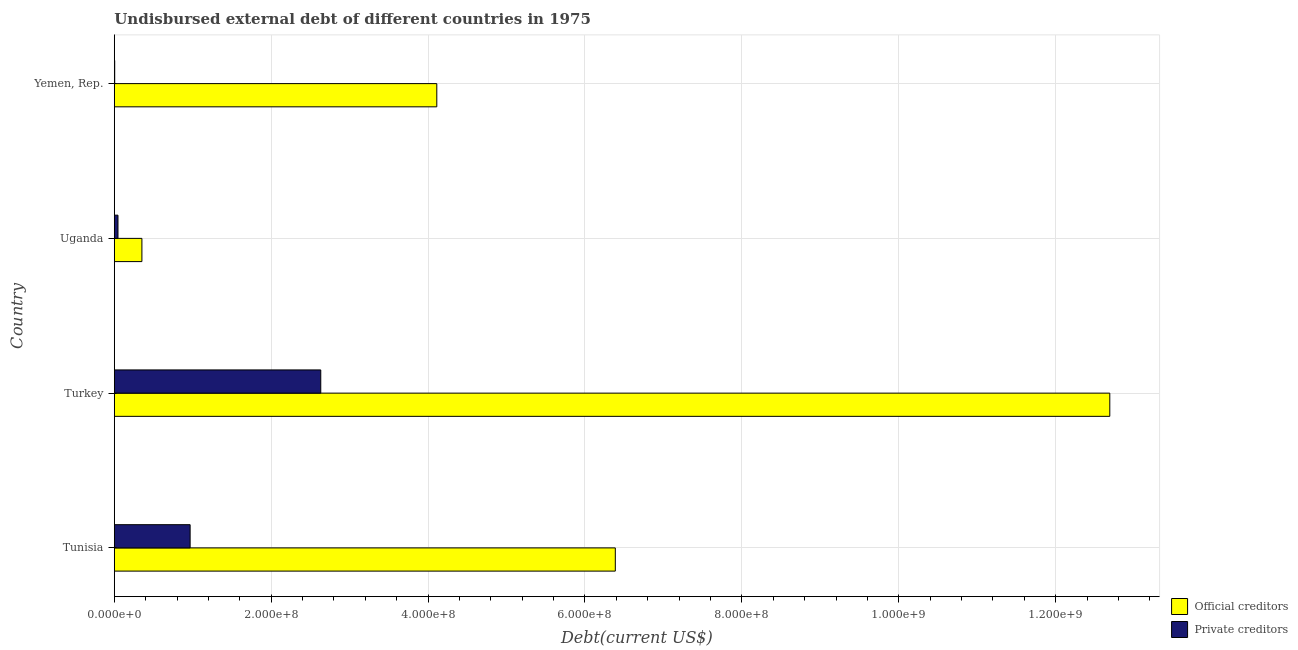Are the number of bars per tick equal to the number of legend labels?
Give a very brief answer. Yes. How many bars are there on the 4th tick from the top?
Ensure brevity in your answer.  2. How many bars are there on the 1st tick from the bottom?
Your answer should be very brief. 2. What is the label of the 1st group of bars from the top?
Offer a terse response. Yemen, Rep. What is the undisbursed external debt of private creditors in Yemen, Rep.?
Provide a succinct answer. 5.02e+05. Across all countries, what is the maximum undisbursed external debt of private creditors?
Make the answer very short. 2.63e+08. Across all countries, what is the minimum undisbursed external debt of private creditors?
Keep it short and to the point. 5.02e+05. In which country was the undisbursed external debt of official creditors minimum?
Provide a succinct answer. Uganda. What is the total undisbursed external debt of official creditors in the graph?
Your answer should be compact. 2.35e+09. What is the difference between the undisbursed external debt of private creditors in Turkey and that in Yemen, Rep.?
Provide a succinct answer. 2.63e+08. What is the difference between the undisbursed external debt of official creditors in Yemen, Rep. and the undisbursed external debt of private creditors in Tunisia?
Your response must be concise. 3.14e+08. What is the average undisbursed external debt of official creditors per country?
Keep it short and to the point. 5.88e+08. What is the difference between the undisbursed external debt of private creditors and undisbursed external debt of official creditors in Yemen, Rep.?
Keep it short and to the point. -4.11e+08. In how many countries, is the undisbursed external debt of official creditors greater than 1040000000 US$?
Give a very brief answer. 1. What is the ratio of the undisbursed external debt of private creditors in Uganda to that in Yemen, Rep.?
Keep it short and to the point. 9.33. Is the undisbursed external debt of official creditors in Turkey less than that in Uganda?
Your answer should be compact. No. Is the difference between the undisbursed external debt of private creditors in Tunisia and Yemen, Rep. greater than the difference between the undisbursed external debt of official creditors in Tunisia and Yemen, Rep.?
Give a very brief answer. No. What is the difference between the highest and the second highest undisbursed external debt of official creditors?
Your answer should be compact. 6.30e+08. What is the difference between the highest and the lowest undisbursed external debt of private creditors?
Provide a short and direct response. 2.63e+08. What does the 1st bar from the top in Turkey represents?
Provide a short and direct response. Private creditors. What does the 2nd bar from the bottom in Tunisia represents?
Ensure brevity in your answer.  Private creditors. Are all the bars in the graph horizontal?
Provide a succinct answer. Yes. How many countries are there in the graph?
Ensure brevity in your answer.  4. Does the graph contain any zero values?
Provide a succinct answer. No. Does the graph contain grids?
Ensure brevity in your answer.  Yes. How are the legend labels stacked?
Make the answer very short. Vertical. What is the title of the graph?
Provide a short and direct response. Undisbursed external debt of different countries in 1975. What is the label or title of the X-axis?
Keep it short and to the point. Debt(current US$). What is the label or title of the Y-axis?
Your response must be concise. Country. What is the Debt(current US$) of Official creditors in Tunisia?
Offer a very short reply. 6.39e+08. What is the Debt(current US$) of Private creditors in Tunisia?
Keep it short and to the point. 9.67e+07. What is the Debt(current US$) of Official creditors in Turkey?
Ensure brevity in your answer.  1.27e+09. What is the Debt(current US$) of Private creditors in Turkey?
Your response must be concise. 2.63e+08. What is the Debt(current US$) in Official creditors in Uganda?
Offer a terse response. 3.52e+07. What is the Debt(current US$) of Private creditors in Uganda?
Keep it short and to the point. 4.68e+06. What is the Debt(current US$) of Official creditors in Yemen, Rep.?
Offer a terse response. 4.11e+08. What is the Debt(current US$) of Private creditors in Yemen, Rep.?
Ensure brevity in your answer.  5.02e+05. Across all countries, what is the maximum Debt(current US$) in Official creditors?
Your response must be concise. 1.27e+09. Across all countries, what is the maximum Debt(current US$) in Private creditors?
Your answer should be compact. 2.63e+08. Across all countries, what is the minimum Debt(current US$) in Official creditors?
Your response must be concise. 3.52e+07. Across all countries, what is the minimum Debt(current US$) in Private creditors?
Provide a succinct answer. 5.02e+05. What is the total Debt(current US$) in Official creditors in the graph?
Your answer should be compact. 2.35e+09. What is the total Debt(current US$) in Private creditors in the graph?
Provide a succinct answer. 3.65e+08. What is the difference between the Debt(current US$) of Official creditors in Tunisia and that in Turkey?
Offer a very short reply. -6.30e+08. What is the difference between the Debt(current US$) in Private creditors in Tunisia and that in Turkey?
Provide a short and direct response. -1.67e+08. What is the difference between the Debt(current US$) in Official creditors in Tunisia and that in Uganda?
Offer a very short reply. 6.03e+08. What is the difference between the Debt(current US$) in Private creditors in Tunisia and that in Uganda?
Offer a very short reply. 9.20e+07. What is the difference between the Debt(current US$) in Official creditors in Tunisia and that in Yemen, Rep.?
Your response must be concise. 2.28e+08. What is the difference between the Debt(current US$) in Private creditors in Tunisia and that in Yemen, Rep.?
Offer a terse response. 9.62e+07. What is the difference between the Debt(current US$) of Official creditors in Turkey and that in Uganda?
Your response must be concise. 1.23e+09. What is the difference between the Debt(current US$) in Private creditors in Turkey and that in Uganda?
Your answer should be very brief. 2.59e+08. What is the difference between the Debt(current US$) of Official creditors in Turkey and that in Yemen, Rep.?
Offer a terse response. 8.58e+08. What is the difference between the Debt(current US$) in Private creditors in Turkey and that in Yemen, Rep.?
Your answer should be compact. 2.63e+08. What is the difference between the Debt(current US$) in Official creditors in Uganda and that in Yemen, Rep.?
Your answer should be very brief. -3.76e+08. What is the difference between the Debt(current US$) of Private creditors in Uganda and that in Yemen, Rep.?
Provide a succinct answer. 4.18e+06. What is the difference between the Debt(current US$) in Official creditors in Tunisia and the Debt(current US$) in Private creditors in Turkey?
Make the answer very short. 3.75e+08. What is the difference between the Debt(current US$) of Official creditors in Tunisia and the Debt(current US$) of Private creditors in Uganda?
Your answer should be compact. 6.34e+08. What is the difference between the Debt(current US$) of Official creditors in Tunisia and the Debt(current US$) of Private creditors in Yemen, Rep.?
Ensure brevity in your answer.  6.38e+08. What is the difference between the Debt(current US$) in Official creditors in Turkey and the Debt(current US$) in Private creditors in Uganda?
Offer a terse response. 1.26e+09. What is the difference between the Debt(current US$) in Official creditors in Turkey and the Debt(current US$) in Private creditors in Yemen, Rep.?
Give a very brief answer. 1.27e+09. What is the difference between the Debt(current US$) in Official creditors in Uganda and the Debt(current US$) in Private creditors in Yemen, Rep.?
Offer a very short reply. 3.47e+07. What is the average Debt(current US$) in Official creditors per country?
Your answer should be compact. 5.88e+08. What is the average Debt(current US$) of Private creditors per country?
Provide a short and direct response. 9.13e+07. What is the difference between the Debt(current US$) in Official creditors and Debt(current US$) in Private creditors in Tunisia?
Give a very brief answer. 5.42e+08. What is the difference between the Debt(current US$) of Official creditors and Debt(current US$) of Private creditors in Turkey?
Ensure brevity in your answer.  1.01e+09. What is the difference between the Debt(current US$) in Official creditors and Debt(current US$) in Private creditors in Uganda?
Offer a terse response. 3.05e+07. What is the difference between the Debt(current US$) of Official creditors and Debt(current US$) of Private creditors in Yemen, Rep.?
Keep it short and to the point. 4.11e+08. What is the ratio of the Debt(current US$) in Official creditors in Tunisia to that in Turkey?
Offer a terse response. 0.5. What is the ratio of the Debt(current US$) in Private creditors in Tunisia to that in Turkey?
Provide a short and direct response. 0.37. What is the ratio of the Debt(current US$) of Official creditors in Tunisia to that in Uganda?
Your response must be concise. 18.15. What is the ratio of the Debt(current US$) in Private creditors in Tunisia to that in Uganda?
Make the answer very short. 20.64. What is the ratio of the Debt(current US$) in Official creditors in Tunisia to that in Yemen, Rep.?
Keep it short and to the point. 1.55. What is the ratio of the Debt(current US$) of Private creditors in Tunisia to that in Yemen, Rep.?
Your response must be concise. 192.54. What is the ratio of the Debt(current US$) in Official creditors in Turkey to that in Uganda?
Offer a terse response. 36.06. What is the ratio of the Debt(current US$) in Private creditors in Turkey to that in Uganda?
Offer a very short reply. 56.21. What is the ratio of the Debt(current US$) in Official creditors in Turkey to that in Yemen, Rep.?
Ensure brevity in your answer.  3.09. What is the ratio of the Debt(current US$) in Private creditors in Turkey to that in Yemen, Rep.?
Provide a short and direct response. 524.29. What is the ratio of the Debt(current US$) of Official creditors in Uganda to that in Yemen, Rep.?
Ensure brevity in your answer.  0.09. What is the ratio of the Debt(current US$) of Private creditors in Uganda to that in Yemen, Rep.?
Your answer should be compact. 9.33. What is the difference between the highest and the second highest Debt(current US$) of Official creditors?
Make the answer very short. 6.30e+08. What is the difference between the highest and the second highest Debt(current US$) of Private creditors?
Ensure brevity in your answer.  1.67e+08. What is the difference between the highest and the lowest Debt(current US$) in Official creditors?
Keep it short and to the point. 1.23e+09. What is the difference between the highest and the lowest Debt(current US$) of Private creditors?
Offer a very short reply. 2.63e+08. 